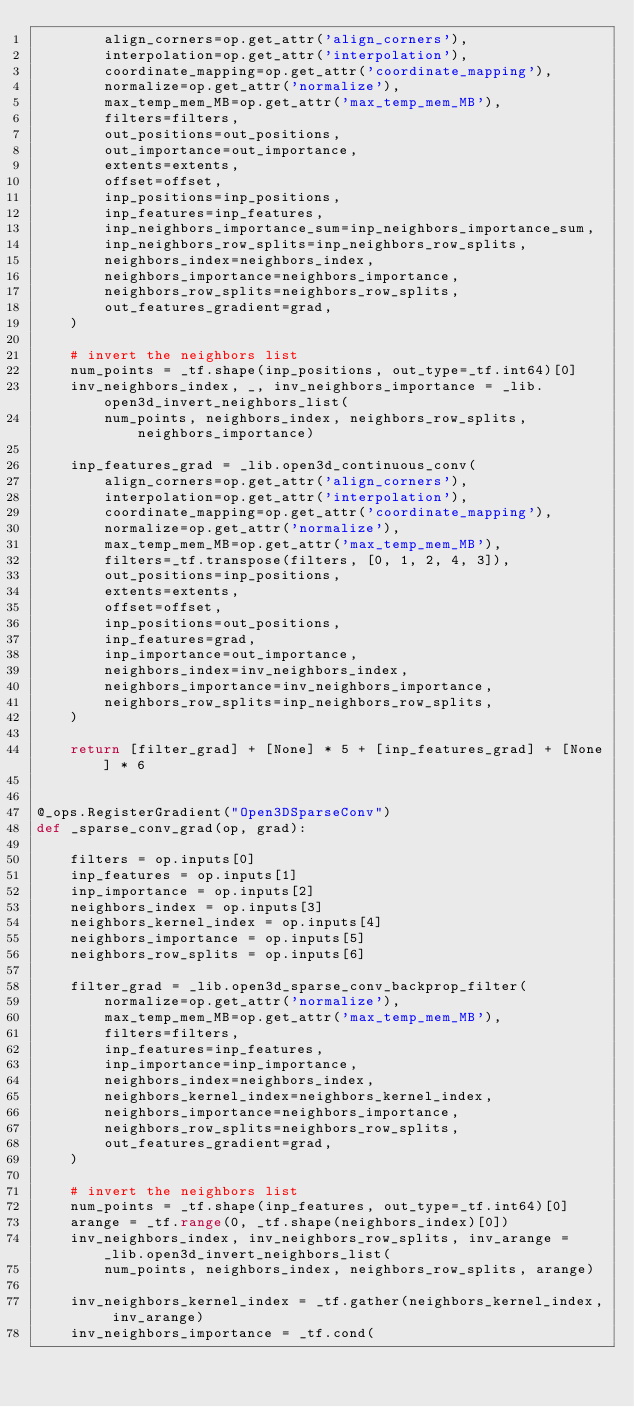Convert code to text. <code><loc_0><loc_0><loc_500><loc_500><_Python_>        align_corners=op.get_attr('align_corners'),
        interpolation=op.get_attr('interpolation'),
        coordinate_mapping=op.get_attr('coordinate_mapping'),
        normalize=op.get_attr('normalize'),
        max_temp_mem_MB=op.get_attr('max_temp_mem_MB'),
        filters=filters,
        out_positions=out_positions,
        out_importance=out_importance,
        extents=extents,
        offset=offset,
        inp_positions=inp_positions,
        inp_features=inp_features,
        inp_neighbors_importance_sum=inp_neighbors_importance_sum,
        inp_neighbors_row_splits=inp_neighbors_row_splits,
        neighbors_index=neighbors_index,
        neighbors_importance=neighbors_importance,
        neighbors_row_splits=neighbors_row_splits,
        out_features_gradient=grad,
    )

    # invert the neighbors list
    num_points = _tf.shape(inp_positions, out_type=_tf.int64)[0]
    inv_neighbors_index, _, inv_neighbors_importance = _lib.open3d_invert_neighbors_list(
        num_points, neighbors_index, neighbors_row_splits, neighbors_importance)

    inp_features_grad = _lib.open3d_continuous_conv(
        align_corners=op.get_attr('align_corners'),
        interpolation=op.get_attr('interpolation'),
        coordinate_mapping=op.get_attr('coordinate_mapping'),
        normalize=op.get_attr('normalize'),
        max_temp_mem_MB=op.get_attr('max_temp_mem_MB'),
        filters=_tf.transpose(filters, [0, 1, 2, 4, 3]),
        out_positions=inp_positions,
        extents=extents,
        offset=offset,
        inp_positions=out_positions,
        inp_features=grad,
        inp_importance=out_importance,
        neighbors_index=inv_neighbors_index,
        neighbors_importance=inv_neighbors_importance,
        neighbors_row_splits=inp_neighbors_row_splits,
    )

    return [filter_grad] + [None] * 5 + [inp_features_grad] + [None] * 6


@_ops.RegisterGradient("Open3DSparseConv")
def _sparse_conv_grad(op, grad):

    filters = op.inputs[0]
    inp_features = op.inputs[1]
    inp_importance = op.inputs[2]
    neighbors_index = op.inputs[3]
    neighbors_kernel_index = op.inputs[4]
    neighbors_importance = op.inputs[5]
    neighbors_row_splits = op.inputs[6]

    filter_grad = _lib.open3d_sparse_conv_backprop_filter(
        normalize=op.get_attr('normalize'),
        max_temp_mem_MB=op.get_attr('max_temp_mem_MB'),
        filters=filters,
        inp_features=inp_features,
        inp_importance=inp_importance,
        neighbors_index=neighbors_index,
        neighbors_kernel_index=neighbors_kernel_index,
        neighbors_importance=neighbors_importance,
        neighbors_row_splits=neighbors_row_splits,
        out_features_gradient=grad,
    )

    # invert the neighbors list
    num_points = _tf.shape(inp_features, out_type=_tf.int64)[0]
    arange = _tf.range(0, _tf.shape(neighbors_index)[0])
    inv_neighbors_index, inv_neighbors_row_splits, inv_arange = _lib.open3d_invert_neighbors_list(
        num_points, neighbors_index, neighbors_row_splits, arange)

    inv_neighbors_kernel_index = _tf.gather(neighbors_kernel_index, inv_arange)
    inv_neighbors_importance = _tf.cond(</code> 